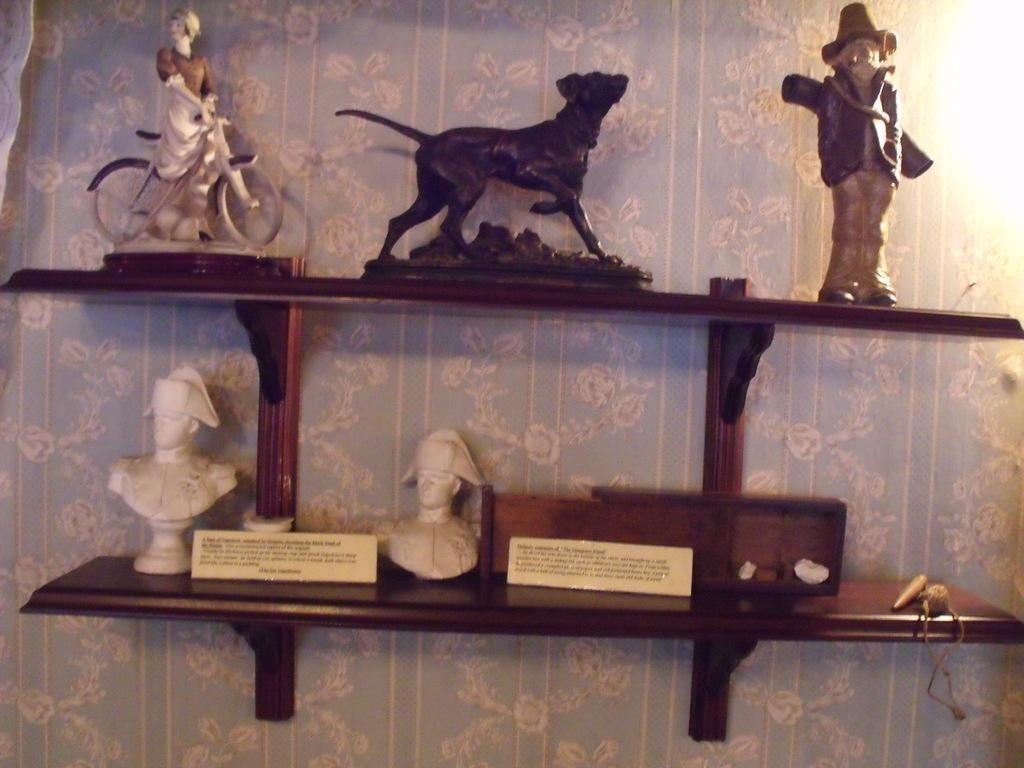What type of objects can be seen in the image? There are small articles in the image. Where are the small articles located? The small articles are on a shelf. How is the shelf attached to the wall? The shelf is fit to the wall. Can you see a snake slithering through the quicksand in the image? There is no snake or quicksand present in the image. 